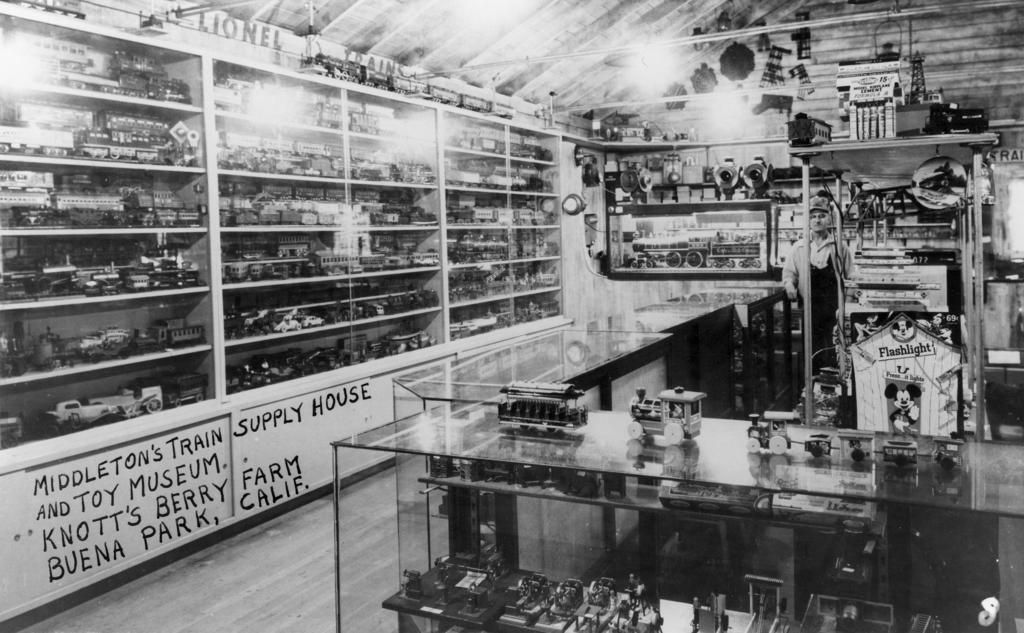<image>
Summarize the visual content of the image. A bunch of shelves in Middleton's Train and Toy Museum display model trains. 